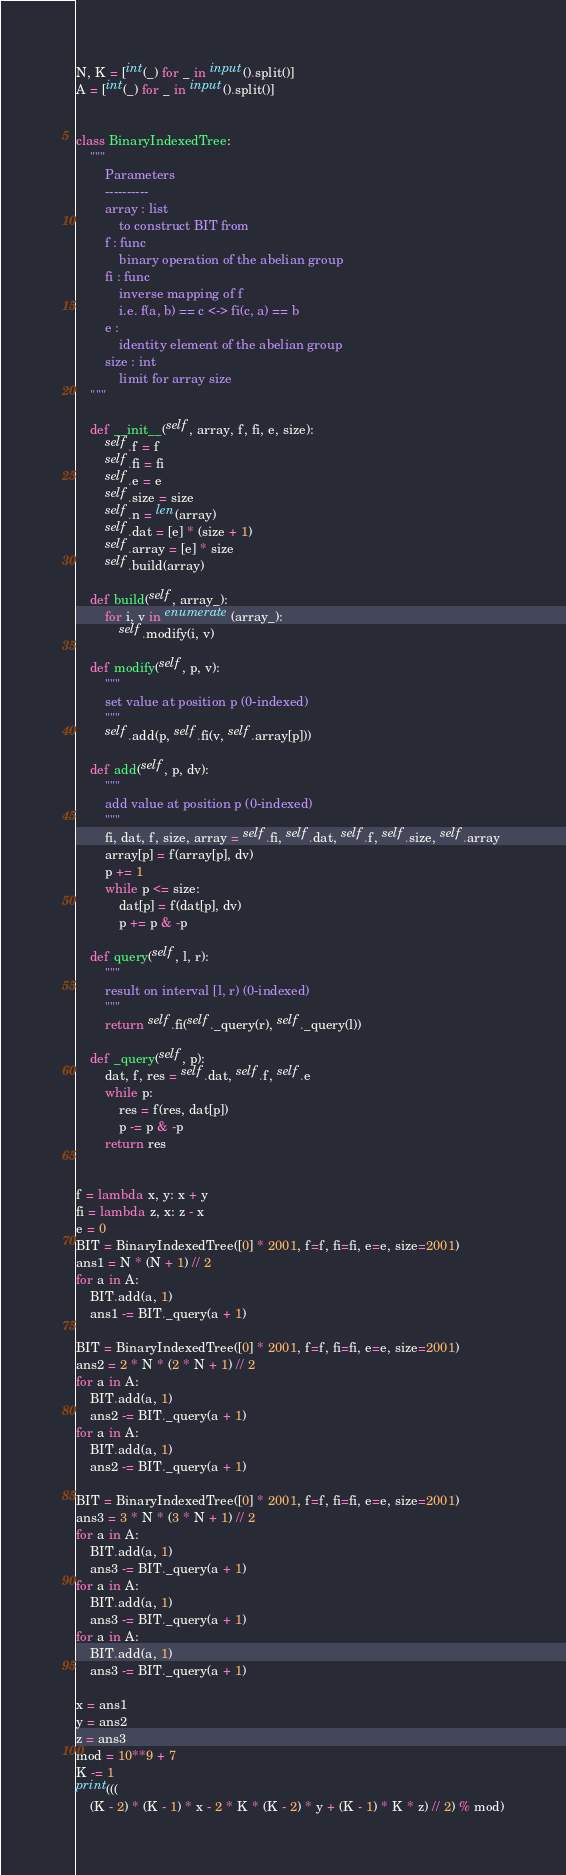Convert code to text. <code><loc_0><loc_0><loc_500><loc_500><_Python_>N, K = [int(_) for _ in input().split()]
A = [int(_) for _ in input().split()]


class BinaryIndexedTree:
    """
        Parameters
        ----------
        array : list
            to construct BIT from
        f : func
            binary operation of the abelian group
        fi : func
            inverse mapping of f
            i.e. f(a, b) == c <-> fi(c, a) == b
        e : 
            identity element of the abelian group
        size : int
            limit for array size
    """

    def __init__(self, array, f, fi, e, size):
        self.f = f
        self.fi = fi
        self.e = e
        self.size = size
        self.n = len(array)
        self.dat = [e] * (size + 1)
        self.array = [e] * size
        self.build(array)

    def build(self, array_):
        for i, v in enumerate(array_):
            self.modify(i, v)

    def modify(self, p, v):
        """
        set value at position p (0-indexed)
        """
        self.add(p, self.fi(v, self.array[p]))

    def add(self, p, dv):
        """
        add value at position p (0-indexed)
        """
        fi, dat, f, size, array = self.fi, self.dat, self.f, self.size, self.array
        array[p] = f(array[p], dv)
        p += 1
        while p <= size:
            dat[p] = f(dat[p], dv)
            p += p & -p

    def query(self, l, r):
        """
        result on interval [l, r) (0-indexed)
        """
        return self.fi(self._query(r), self._query(l))

    def _query(self, p):
        dat, f, res = self.dat, self.f, self.e
        while p:
            res = f(res, dat[p])
            p -= p & -p
        return res


f = lambda x, y: x + y
fi = lambda z, x: z - x
e = 0
BIT = BinaryIndexedTree([0] * 2001, f=f, fi=fi, e=e, size=2001)
ans1 = N * (N + 1) // 2
for a in A:
    BIT.add(a, 1)
    ans1 -= BIT._query(a + 1)

BIT = BinaryIndexedTree([0] * 2001, f=f, fi=fi, e=e, size=2001)
ans2 = 2 * N * (2 * N + 1) // 2
for a in A:
    BIT.add(a, 1)
    ans2 -= BIT._query(a + 1)
for a in A:
    BIT.add(a, 1)
    ans2 -= BIT._query(a + 1)

BIT = BinaryIndexedTree([0] * 2001, f=f, fi=fi, e=e, size=2001)
ans3 = 3 * N * (3 * N + 1) // 2
for a in A:
    BIT.add(a, 1)
    ans3 -= BIT._query(a + 1)
for a in A:
    BIT.add(a, 1)
    ans3 -= BIT._query(a + 1)
for a in A:
    BIT.add(a, 1)
    ans3 -= BIT._query(a + 1)

x = ans1
y = ans2
z = ans3
mod = 10**9 + 7
K -= 1
print(((
    (K - 2) * (K - 1) * x - 2 * K * (K - 2) * y + (K - 1) * K * z) // 2) % mod)
</code> 